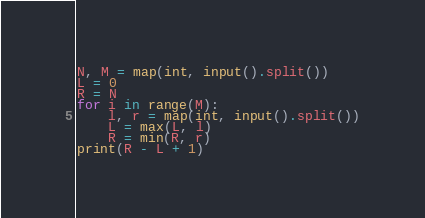<code> <loc_0><loc_0><loc_500><loc_500><_Python_>N, M = map(int, input().split())
L = 0
R = N
for i in range(M):
    l, r = map(int, input().split())
    L = max(L, l)
    R = min(R, r)
print(R - L + 1)</code> 